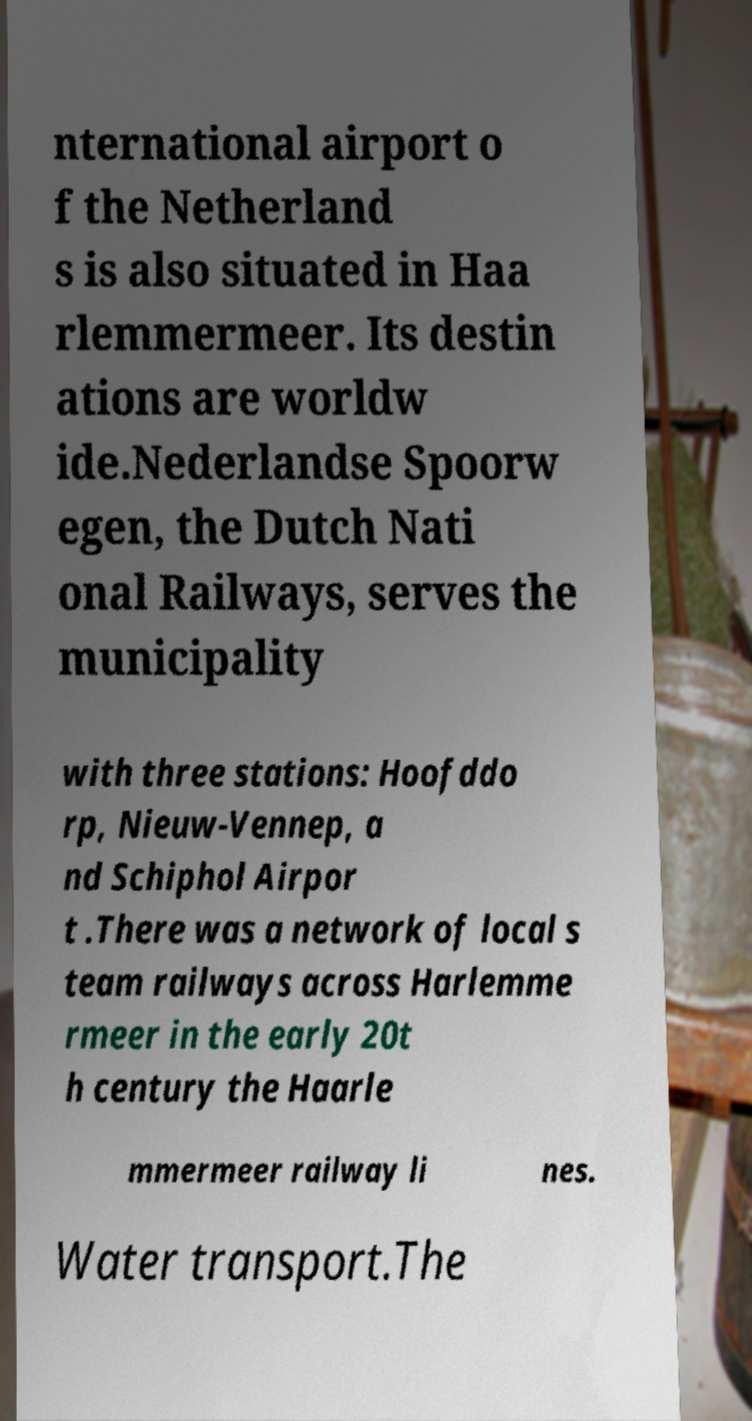I need the written content from this picture converted into text. Can you do that? nternational airport o f the Netherland s is also situated in Haa rlemmermeer. Its destin ations are worldw ide.Nederlandse Spoorw egen, the Dutch Nati onal Railways, serves the municipality with three stations: Hoofddo rp, Nieuw-Vennep, a nd Schiphol Airpor t .There was a network of local s team railways across Harlemme rmeer in the early 20t h century the Haarle mmermeer railway li nes. Water transport.The 